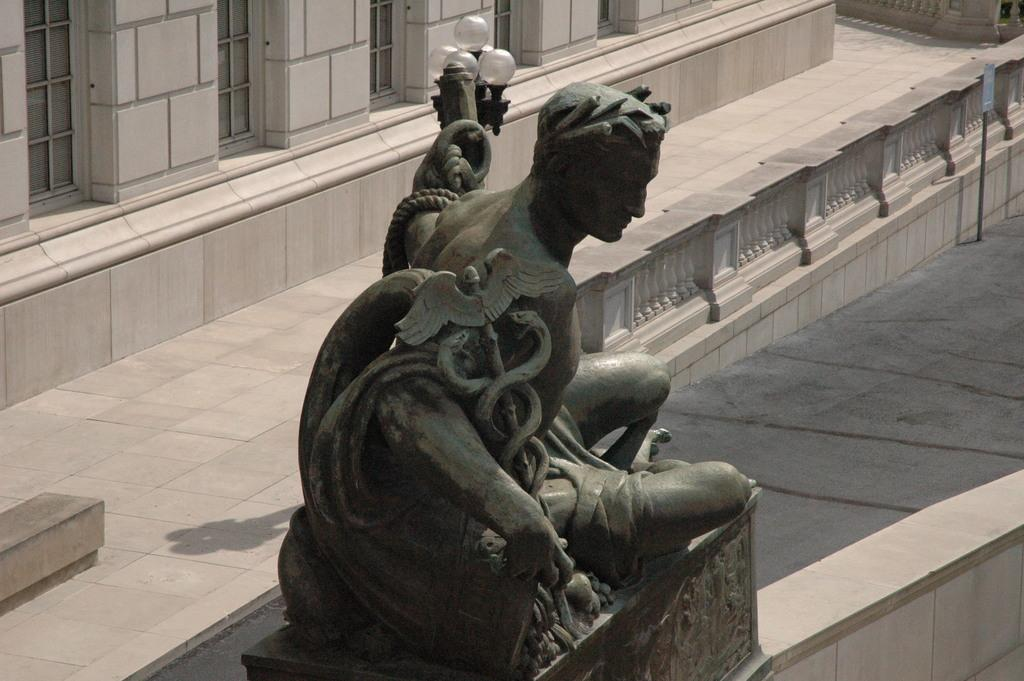What is the main subject in the middle of the image? There is a sculpture in the middle of the image. What can be seen in the background of the image? There is a building and a glass window in the background of the image. How does the sculpture compare to a school in the image? There is no school present in the image, so it cannot be compared to the sculpture. 